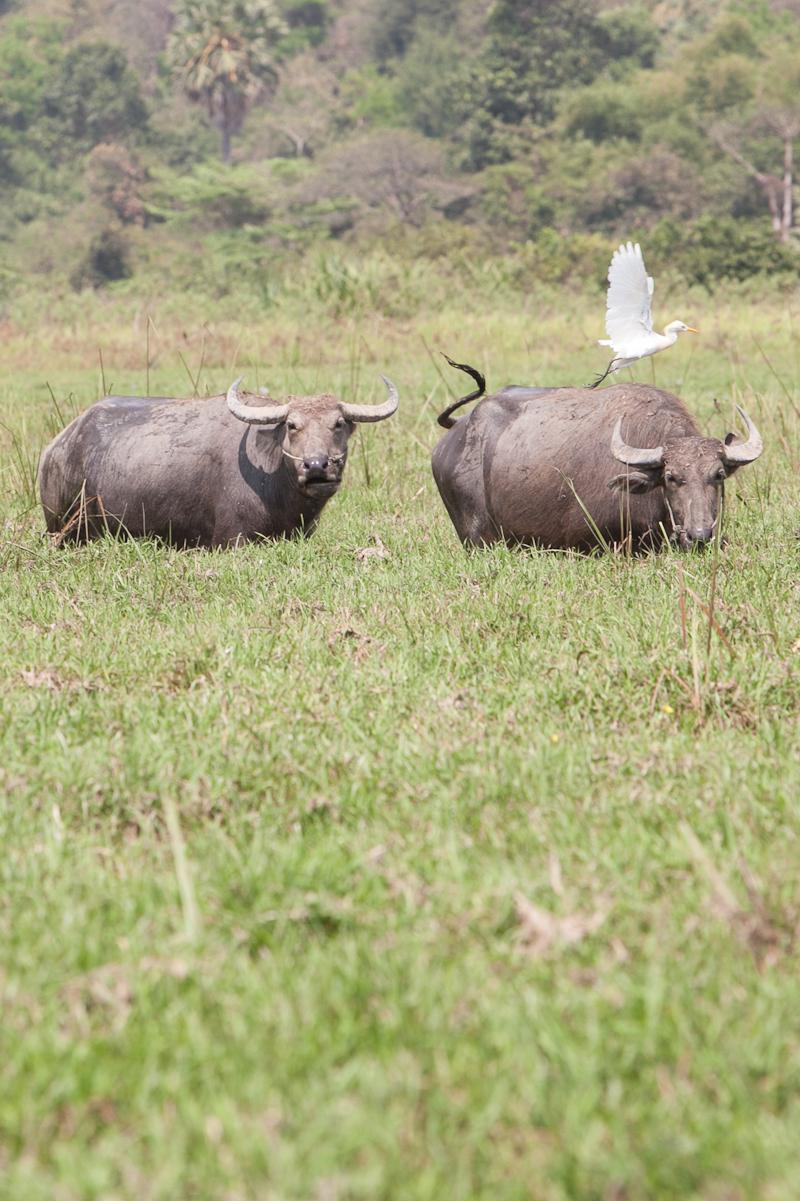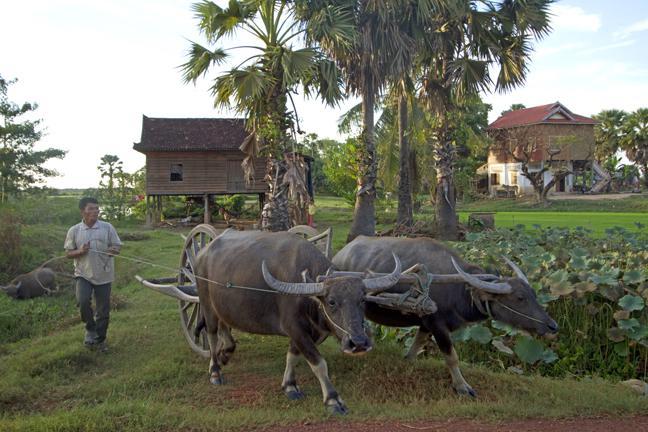The first image is the image on the left, the second image is the image on the right. Assess this claim about the two images: "A young person wearing head covering is sitting astride a horned animal.". Correct or not? Answer yes or no. No. The first image is the image on the left, the second image is the image on the right. Examine the images to the left and right. Is the description "One of the pictures shows a boy riding a water buffalo, and the other shows two water buffalo together." accurate? Answer yes or no. No. 